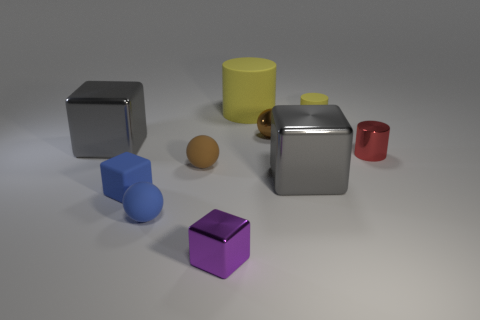The matte thing that is the same color as the metallic sphere is what shape?
Give a very brief answer. Sphere. What is the shape of the big yellow matte object?
Your answer should be compact. Cylinder. What number of other things are the same shape as the purple object?
Provide a short and direct response. 3. What is the color of the ball that is right of the large yellow cylinder?
Your answer should be compact. Brown. Are the small blue ball and the small red cylinder made of the same material?
Keep it short and to the point. No. What number of things are either red cylinders or small objects behind the small purple cube?
Your answer should be very brief. 6. The rubber sphere that is the same color as the metallic sphere is what size?
Offer a terse response. Small. What shape is the metallic thing that is in front of the rubber cube?
Ensure brevity in your answer.  Cube. Do the small matte thing behind the red metal cylinder and the large matte thing have the same color?
Your answer should be very brief. Yes. There is a object that is the same color as the big cylinder; what is it made of?
Give a very brief answer. Rubber. 